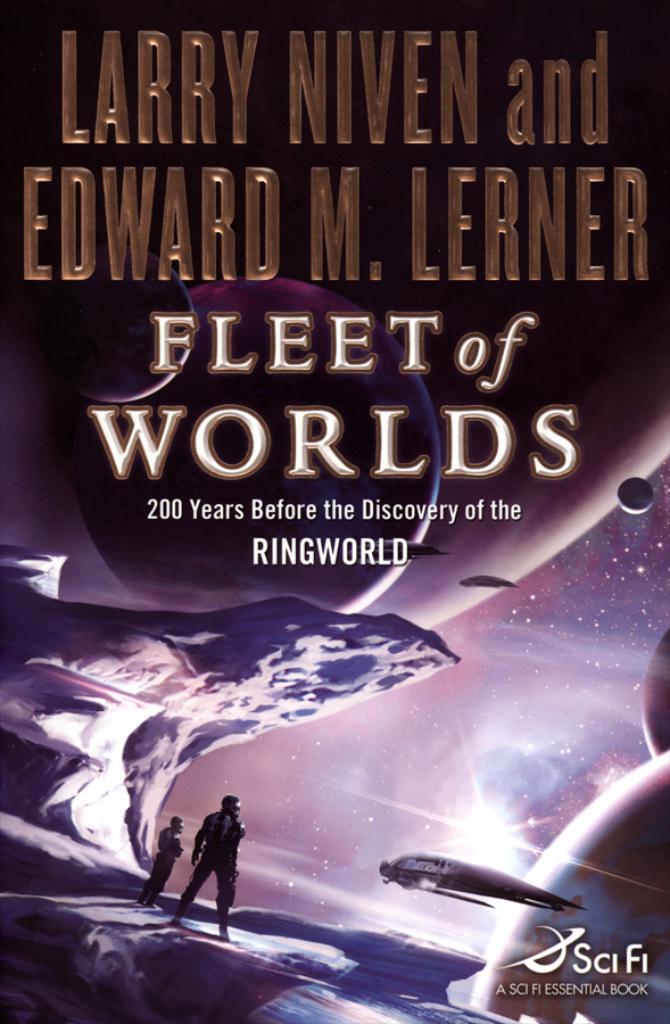What is the title of the book?
Give a very brief answer. Fleet of worlds. 